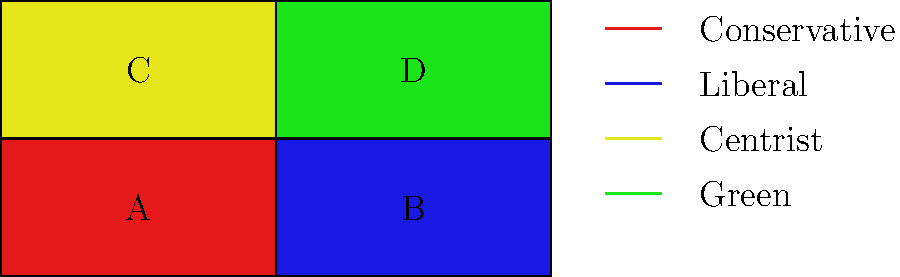Based on the color-coded political ideology map of a fictional country divided into four regions (A, B, C, and D), which region is most likely to support environmental policies and sustainable development initiatives? To answer this question, we need to analyze the color-coding of the map and its corresponding legend:

1. Region A (top-left) is colored red, which represents Conservative ideology.
2. Region B (top-right) is colored blue, representing Liberal ideology.
3. Region C (bottom-left) is colored yellow, indicating Centrist ideology.
4. Region D (bottom-right) is colored green, which represents Green ideology.

The Green ideology is typically associated with environmental protection, sustainable development, and eco-friendly policies. Therefore, the region most likely to support environmental policies and sustainable development initiatives would be the one colored green.

Step-by-step reasoning:
1. Identify the color-coding for each region.
2. Match the colors to their corresponding ideologies using the legend.
3. Recognize that the Green ideology is most closely aligned with environmental policies.
4. Locate the green-colored region on the map.

The green-colored region is Region D, located in the bottom-right quadrant of the map.
Answer: Region D 